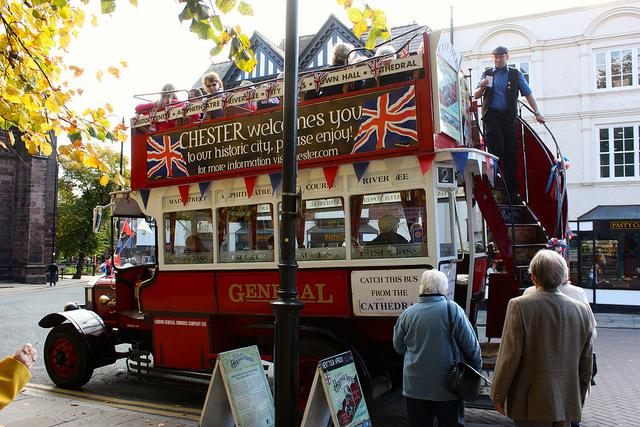The flag on the bus belongs to which Country?

Choices:
A) united states
B) united kingdom
C) switzerland
D) brazil united kingdom 